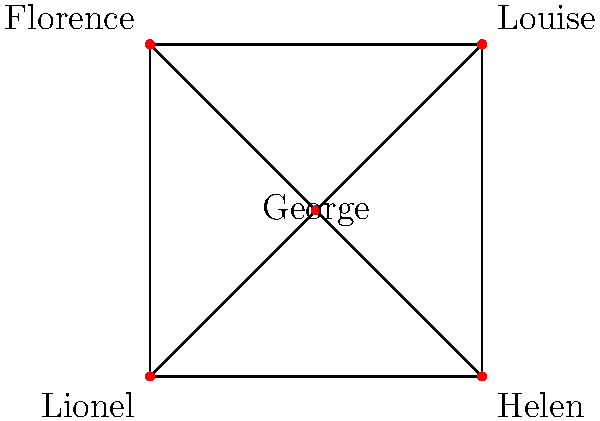In the graph representing character interactions in The Jeffersons, how many automorphisms (symmetries) exist that preserve the structure of the graph while potentially swapping character positions? To determine the number of automorphisms in this graph:

1. Observe that the graph is a complete graph $K_5$, where every character is connected to every other character.

2. In a complete graph, any permutation of vertices preserves the graph structure, as all vertices are connected to all others.

3. The number of automorphisms in a complete graph $K_n$ is equal to the number of permutations of $n$ elements, which is $n!$.

4. In this case, we have 5 characters, so $n = 5$.

5. Therefore, the number of automorphisms is $5! = 5 \times 4 \times 3 \times 2 \times 1 = 120$.

This high number of symmetries reflects the equal importance and interconnectedness of all characters in The Jeffersons, highlighting the show's ensemble nature and its exploration of various social dynamics among all characters.
Answer: 120 